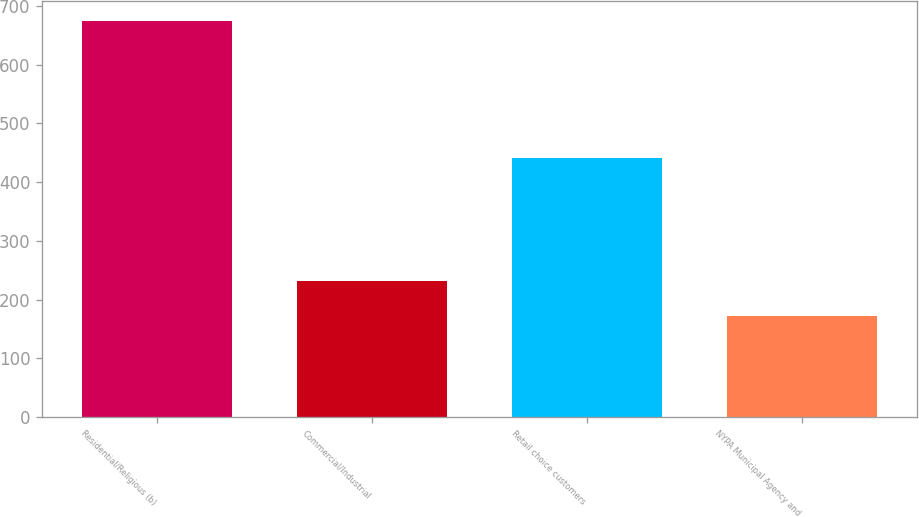<chart> <loc_0><loc_0><loc_500><loc_500><bar_chart><fcel>Residential/Religious (b)<fcel>Commercial/Industrial<fcel>Retail choice customers<fcel>NYPA Municipal Agency and<nl><fcel>675<fcel>232<fcel>441<fcel>172<nl></chart> 